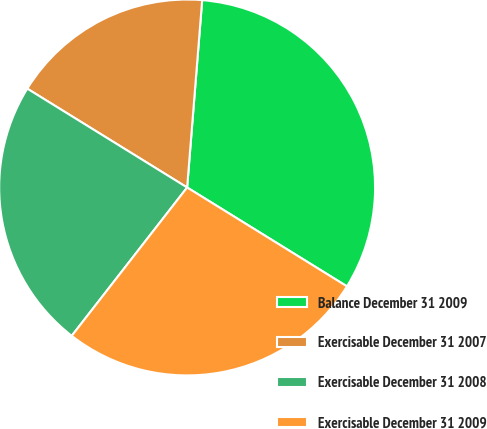<chart> <loc_0><loc_0><loc_500><loc_500><pie_chart><fcel>Balance December 31 2009<fcel>Exercisable December 31 2007<fcel>Exercisable December 31 2008<fcel>Exercisable December 31 2009<nl><fcel>32.54%<fcel>17.46%<fcel>23.29%<fcel>26.7%<nl></chart> 